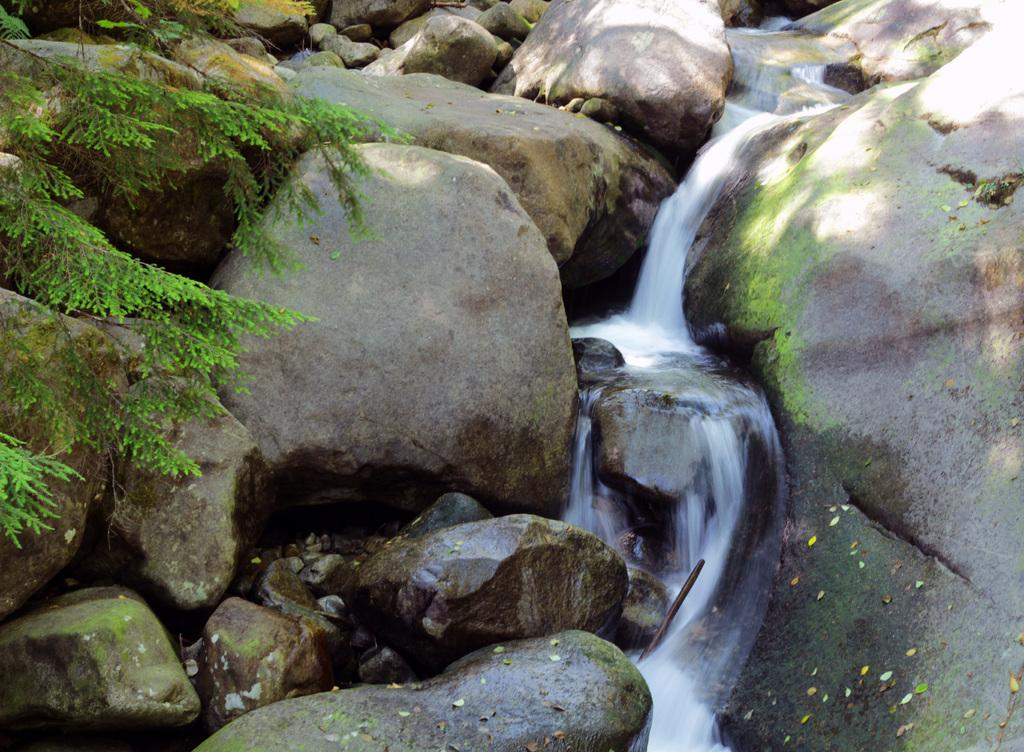What natural feature is the main subject of the image? There is a waterfall in the image. What other elements can be seen in the image? Rocks and the branches of trees are visible in the image. What type of crime is being committed near the waterfall in the image? There is no crime or criminal activity depicted in the image; it features a waterfall, rocks, and tree branches. What kind of lead can be seen in the image? There is no lead present in the image; it features a waterfall, rocks, and tree branches. 